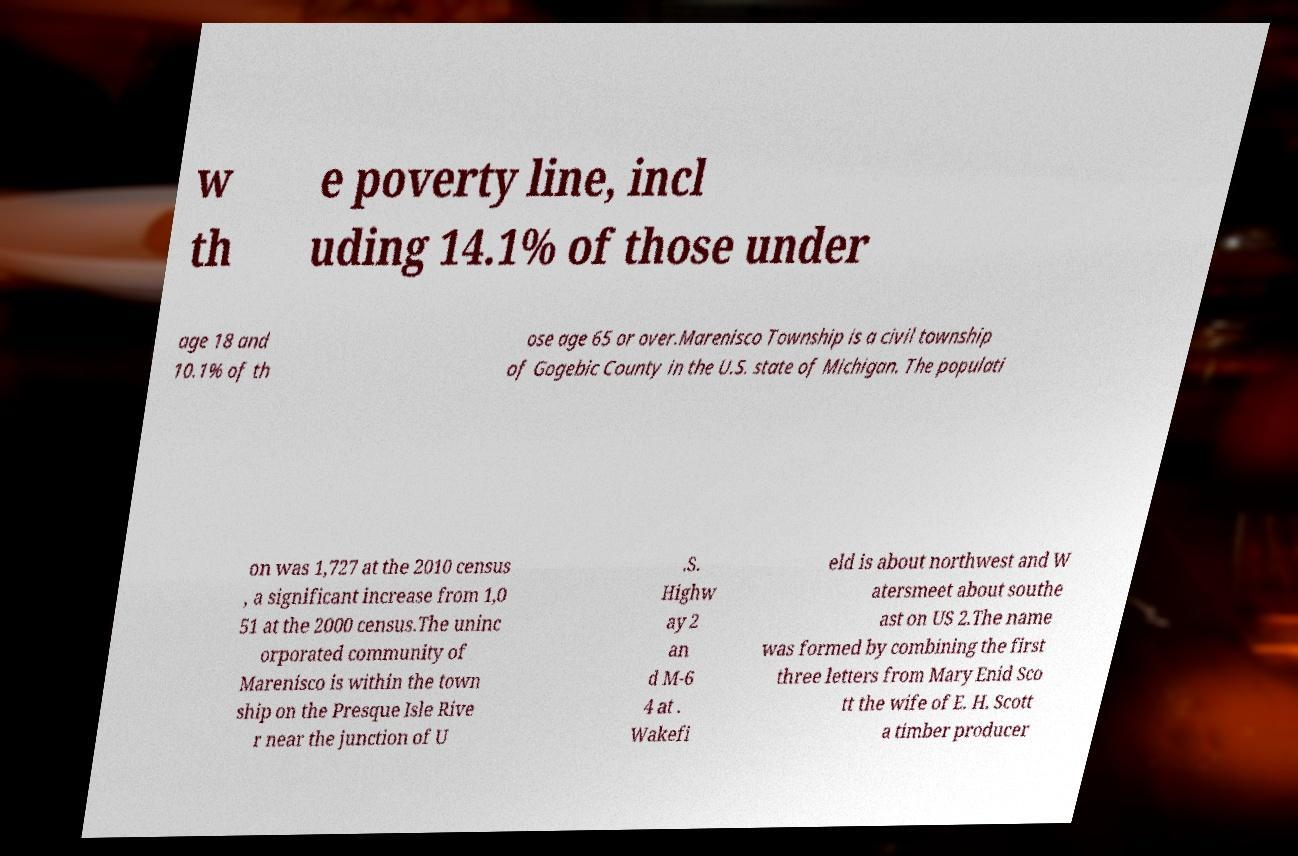Can you accurately transcribe the text from the provided image for me? w th e poverty line, incl uding 14.1% of those under age 18 and 10.1% of th ose age 65 or over.Marenisco Township is a civil township of Gogebic County in the U.S. state of Michigan. The populati on was 1,727 at the 2010 census , a significant increase from 1,0 51 at the 2000 census.The uninc orporated community of Marenisco is within the town ship on the Presque Isle Rive r near the junction of U .S. Highw ay 2 an d M-6 4 at . Wakefi eld is about northwest and W atersmeet about southe ast on US 2.The name was formed by combining the first three letters from Mary Enid Sco tt the wife of E. H. Scott a timber producer 